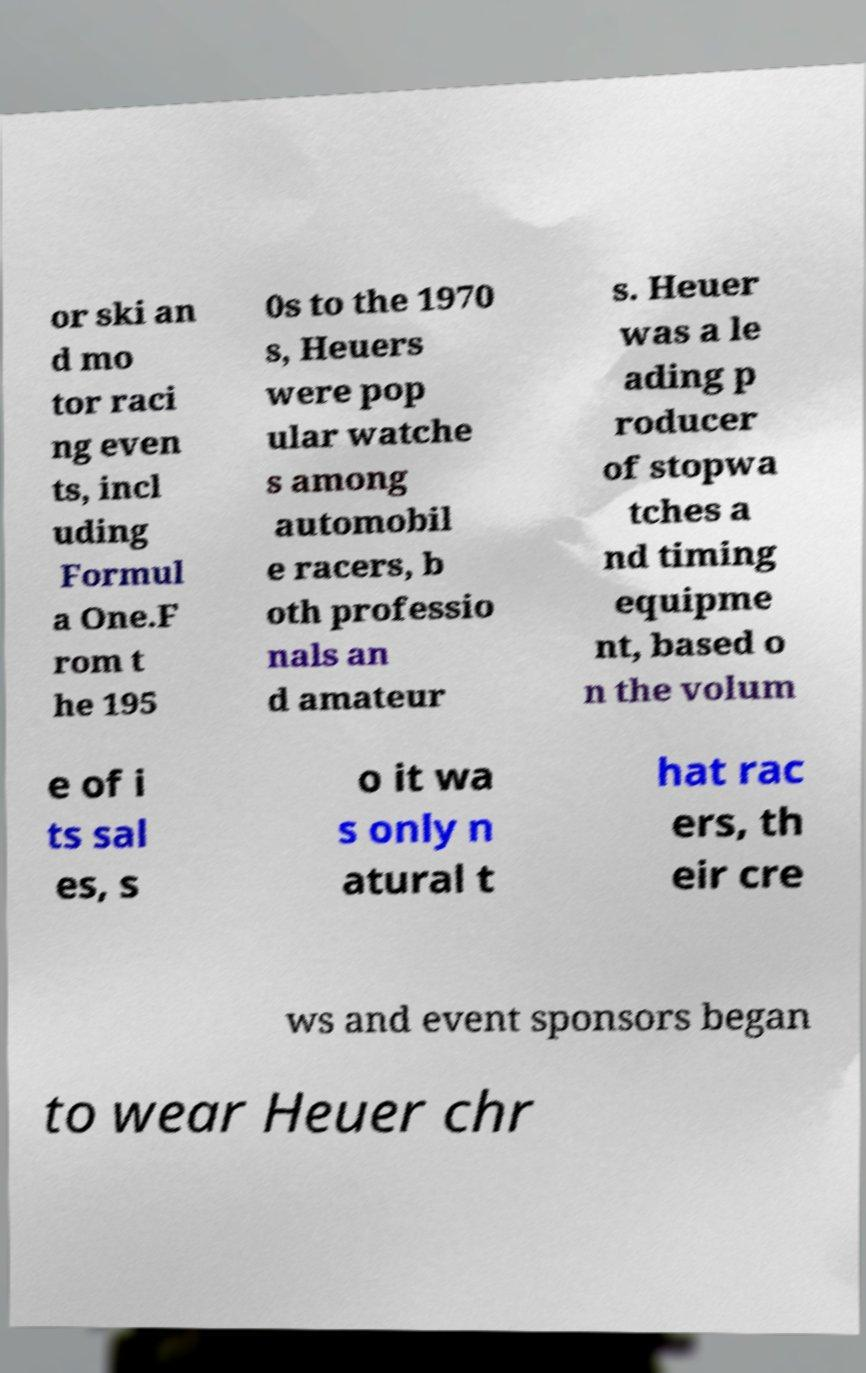Could you assist in decoding the text presented in this image and type it out clearly? or ski an d mo tor raci ng even ts, incl uding Formul a One.F rom t he 195 0s to the 1970 s, Heuers were pop ular watche s among automobil e racers, b oth professio nals an d amateur s. Heuer was a le ading p roducer of stopwa tches a nd timing equipme nt, based o n the volum e of i ts sal es, s o it wa s only n atural t hat rac ers, th eir cre ws and event sponsors began to wear Heuer chr 